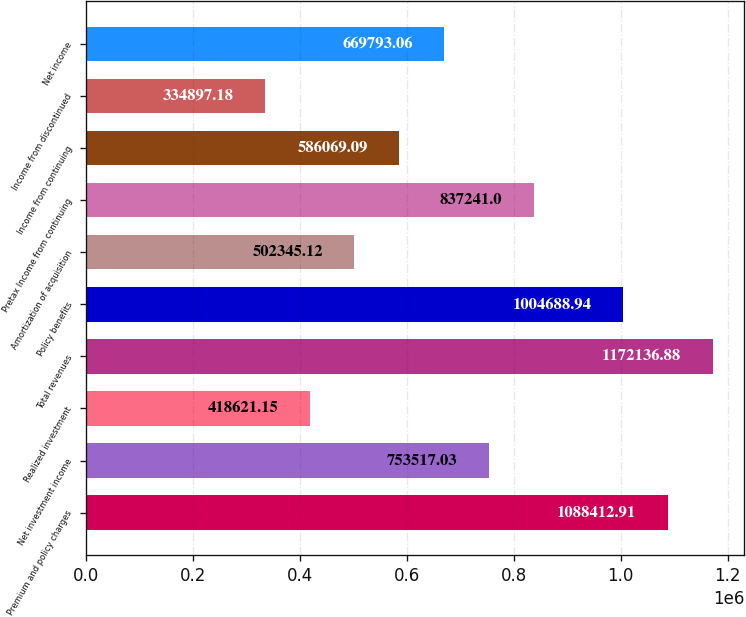Convert chart. <chart><loc_0><loc_0><loc_500><loc_500><bar_chart><fcel>Premium and policy charges<fcel>Net investment income<fcel>Realized investment<fcel>Total revenues<fcel>Policy benefits<fcel>Amortization of acquisition<fcel>Pretax Income from continuing<fcel>Income from continuing<fcel>Income from discontinued<fcel>Net income<nl><fcel>1.08841e+06<fcel>753517<fcel>418621<fcel>1.17214e+06<fcel>1.00469e+06<fcel>502345<fcel>837241<fcel>586069<fcel>334897<fcel>669793<nl></chart> 